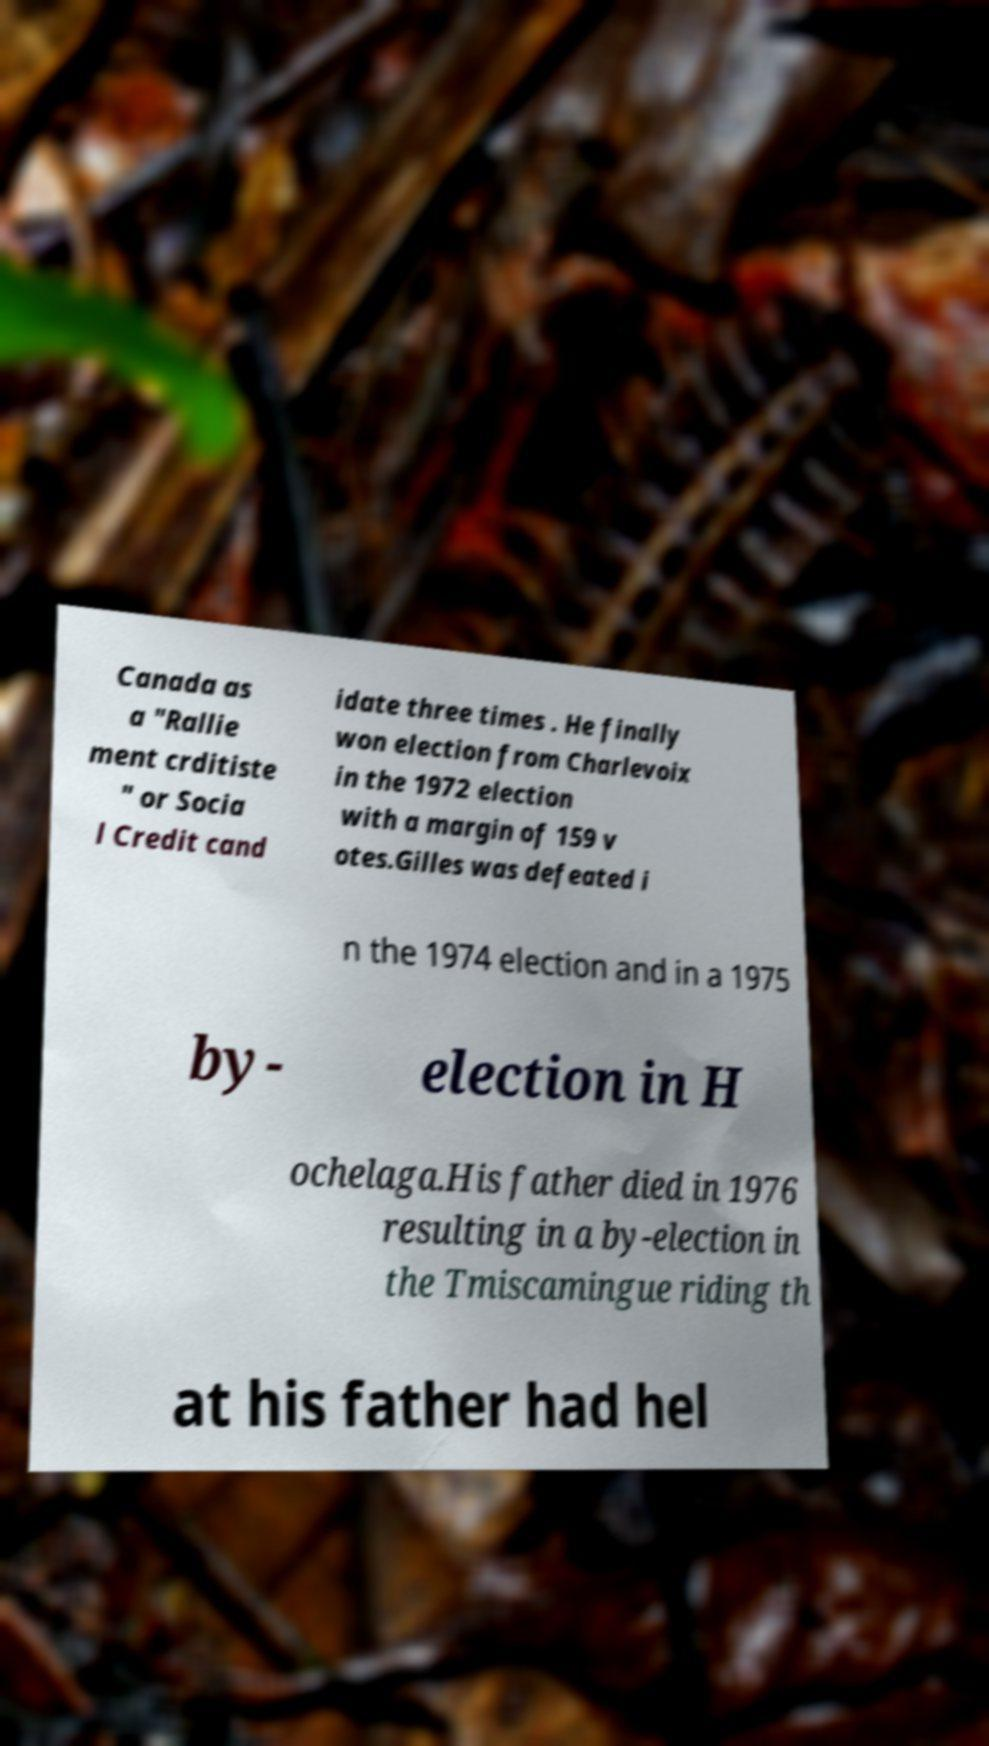Can you read and provide the text displayed in the image?This photo seems to have some interesting text. Can you extract and type it out for me? Canada as a "Rallie ment crditiste " or Socia l Credit cand idate three times . He finally won election from Charlevoix in the 1972 election with a margin of 159 v otes.Gilles was defeated i n the 1974 election and in a 1975 by- election in H ochelaga.His father died in 1976 resulting in a by-election in the Tmiscamingue riding th at his father had hel 